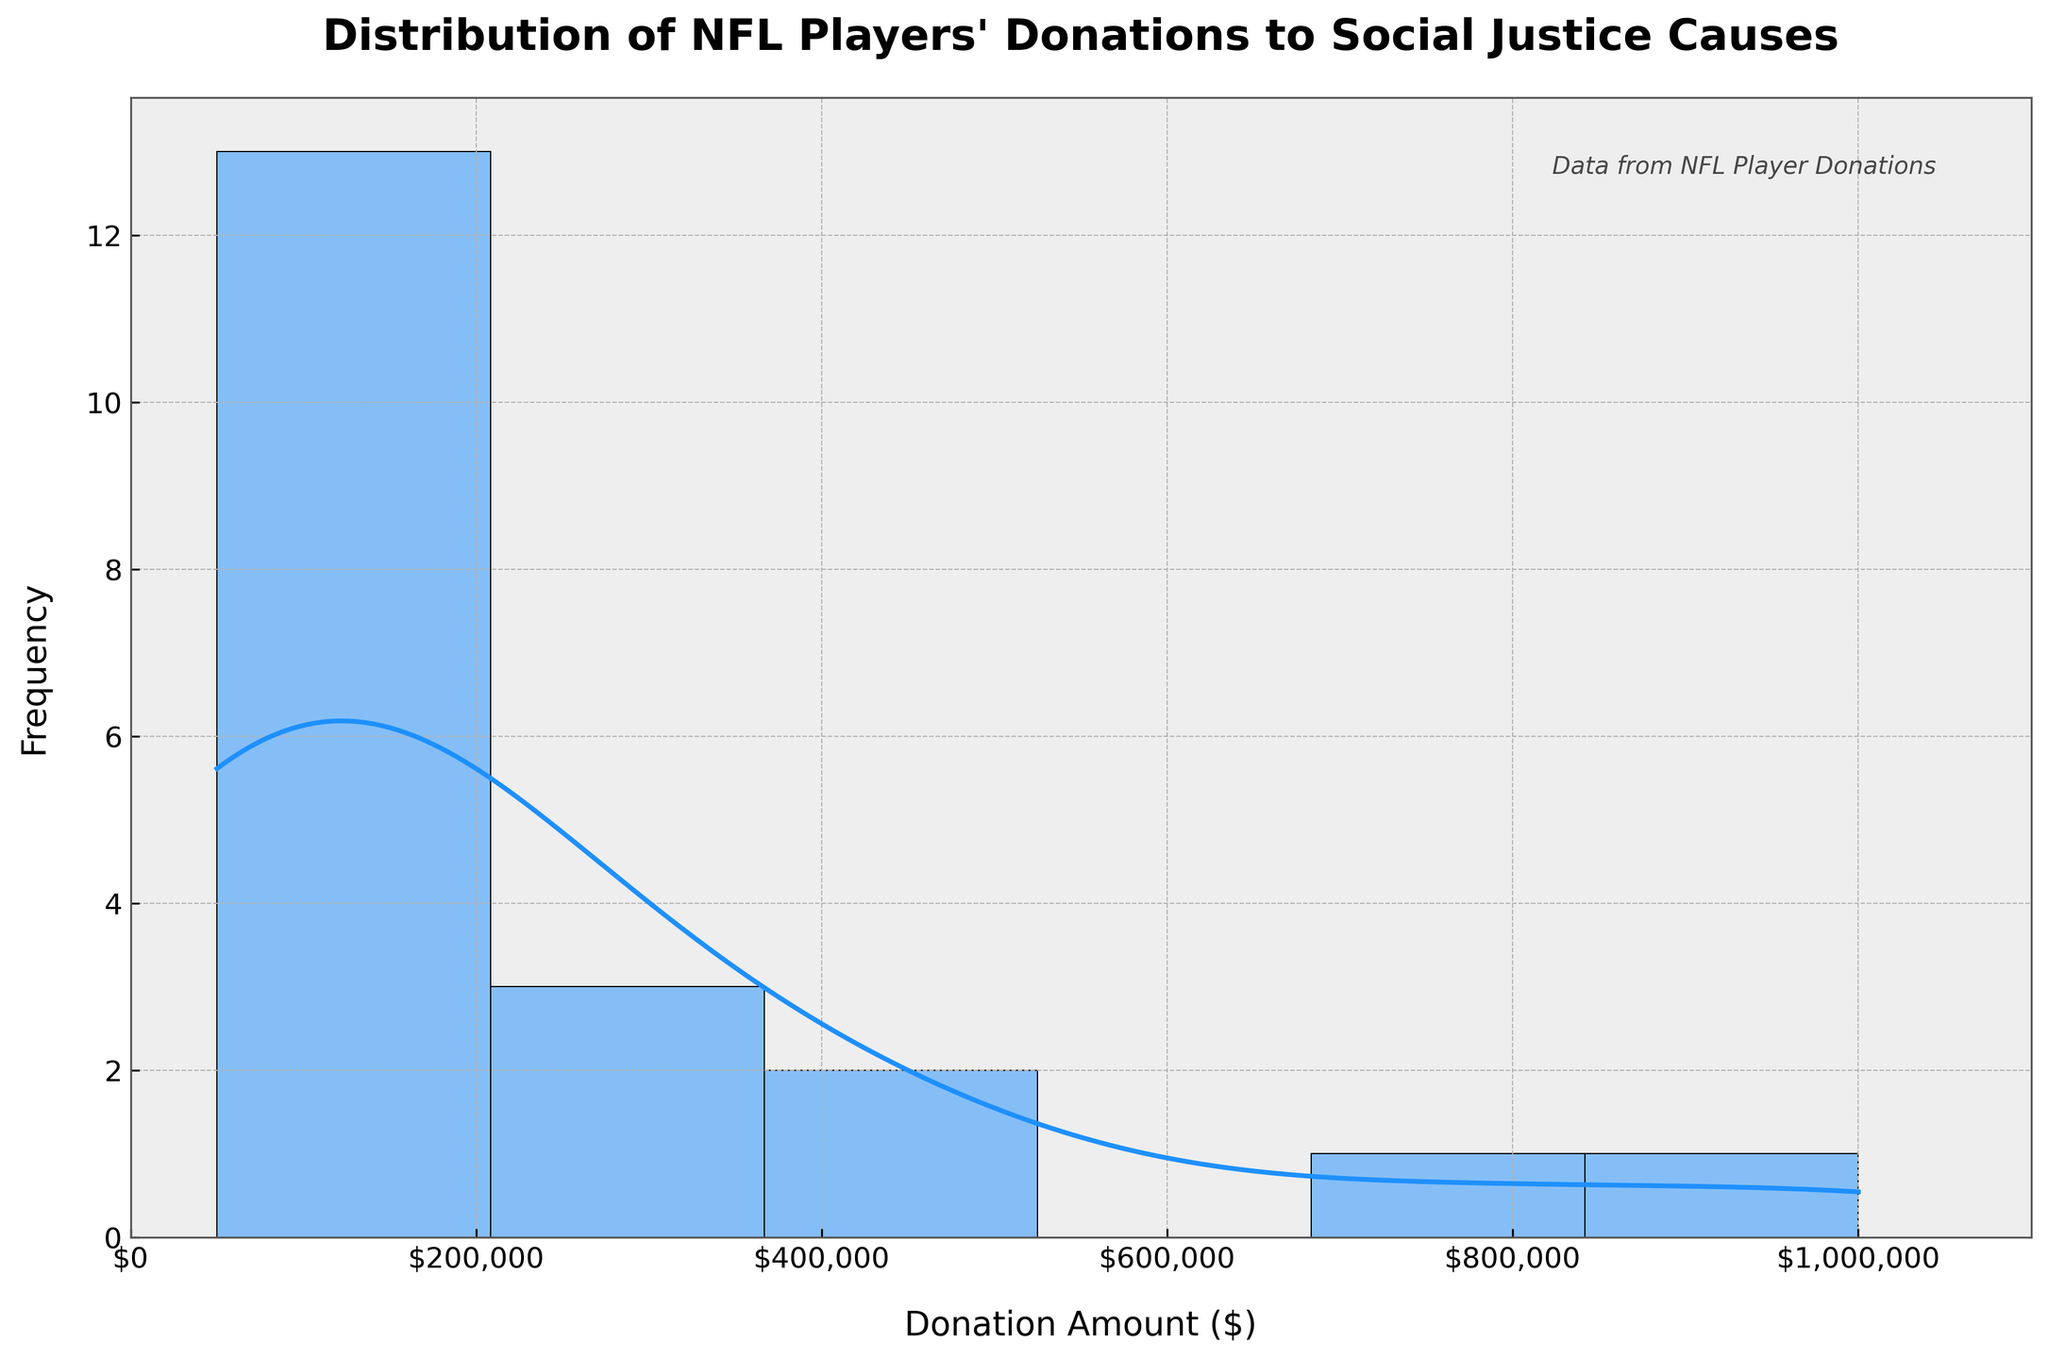What's the title of the figure? The title is usually displayed at the top of the figure.
Answer: Distribution of NFL Players' Donations to Social Justice Causes What do the x-axis and y-axis represent? The x-axis represents the Donation Amount ($), and the y-axis represents the frequency of those donations. This can be determined by the labels on each axis.
Answer: Donation Amount ($) and Frequency What is the highest donation amount shown? The x-axis ranges up to $1,100,000, but the highest donation amount shown by a player is indicated close to $1,000,000. Observing the histogram, a large peak towards the $1,000,000 mark confirms this.
Answer: $1,000,000 How many players donated more than $500,000? By examining the histogram, we can see that there are bars representing donations between the $500,000 and $1,000,000 range. Each bar represents one player, so count these bars.
Answer: 4 players What's the most common donation range? To identify the most common donation range, look for the highest bars in the histogram. These bars will indicate the donation range with the highest frequency.
Answer: $50,000 - $100,000 How is the KDE (Density Curve) useful in this figure? The KDE curve helps to visualize the distribution of donation amounts more smoothly than the histogram alone, showing the density of players' donations across different ranges. This is indicated by the smooth line overlaid on the histogram.
Answer: It shows the density of donation amounts Which player donated almost $900,000 less than the highest donor? The highest donor gave $1,000,000. To find who donated $900,000 less, look for a player who donated close to $100,000. According to the data, Doug Baldwin donated $100,000.
Answer: Doug Baldwin What is the range of donation amounts that the x-axis covers? The x-axis starts at $0 and ends at $1,100,000. This can be seen from the x-axis labels and the axis limits.
Answer: $0 to $1,100,000 What's the frequency of donations around $100,000 compared to $300,000? Observing the histogram bars around $100,000 and $300,000, compare the height of the bars. The higher the bar, the greater the frequency.
Answer: Higher around $100,000 Is there a visible outlier in the donations? An outlier in this context would be a donation amount significantly higher or lower than the others. The highest bar close to $1,000,000 indicates such an outlier, confirmed by the data for Colin Kaepernick.
Answer: Yes, $1,000,000 